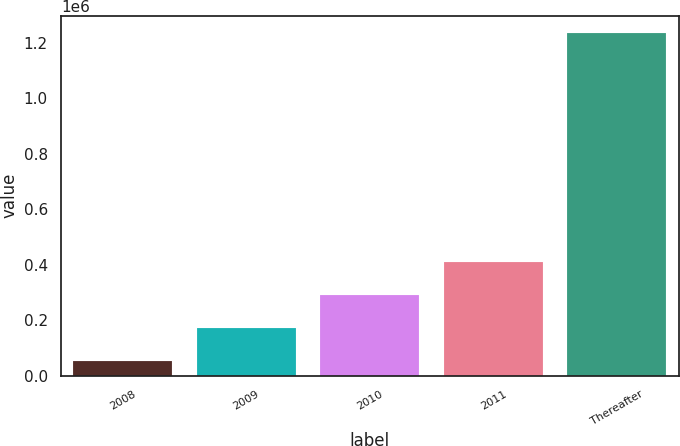<chart> <loc_0><loc_0><loc_500><loc_500><bar_chart><fcel>2008<fcel>2009<fcel>2010<fcel>2011<fcel>Thereafter<nl><fcel>53330<fcel>171561<fcel>289792<fcel>408022<fcel>1.23564e+06<nl></chart> 